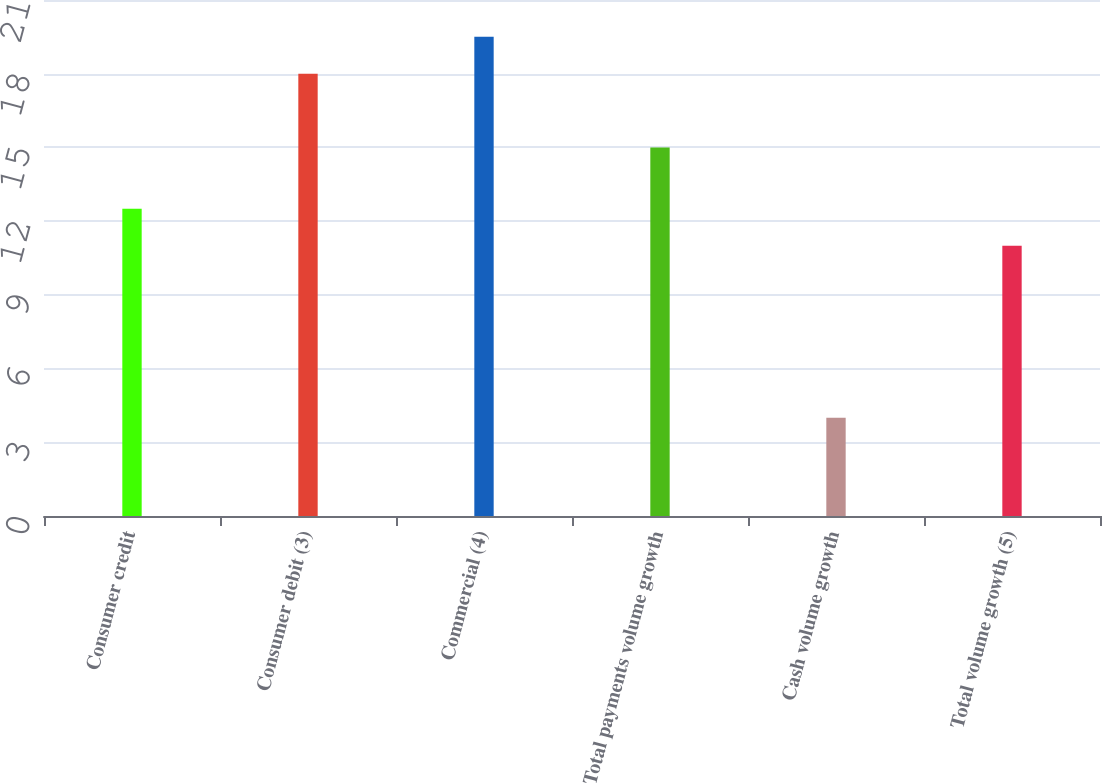Convert chart. <chart><loc_0><loc_0><loc_500><loc_500><bar_chart><fcel>Consumer credit<fcel>Consumer debit (3)<fcel>Commercial (4)<fcel>Total payments volume growth<fcel>Cash volume growth<fcel>Total volume growth (5)<nl><fcel>12.5<fcel>18<fcel>19.5<fcel>15<fcel>4<fcel>11<nl></chart> 